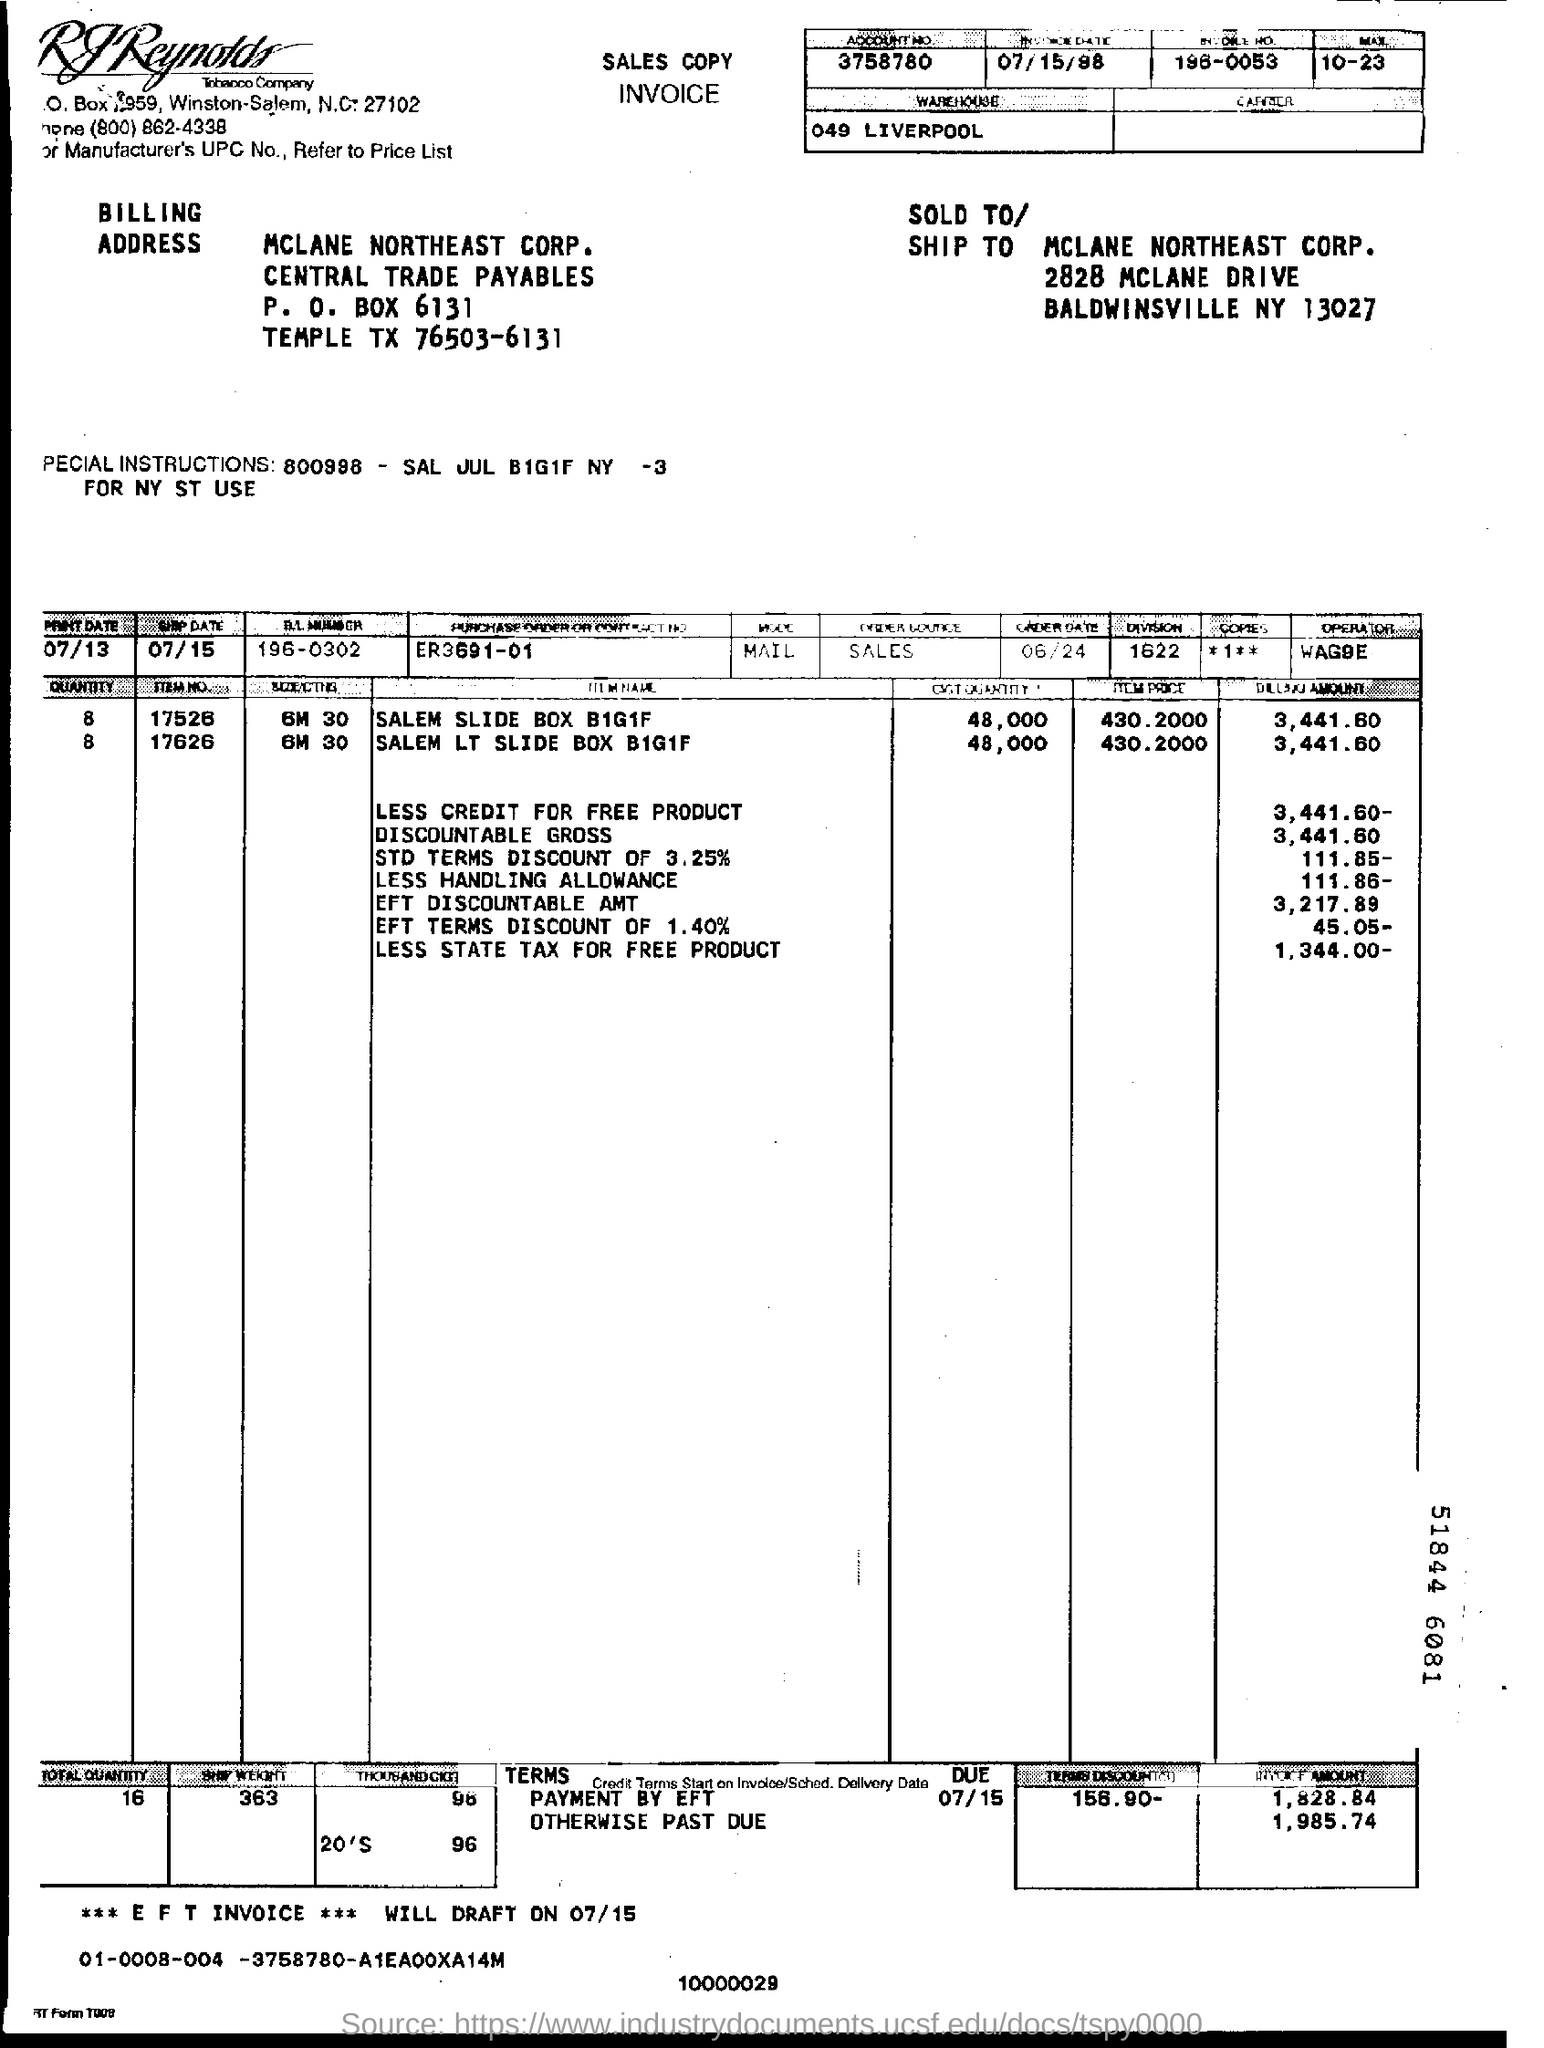Highlight a few significant elements in this photo. The location of the warehouse is in Liverpool. What is the account number on the sales copy invoice? It is 3758780... 